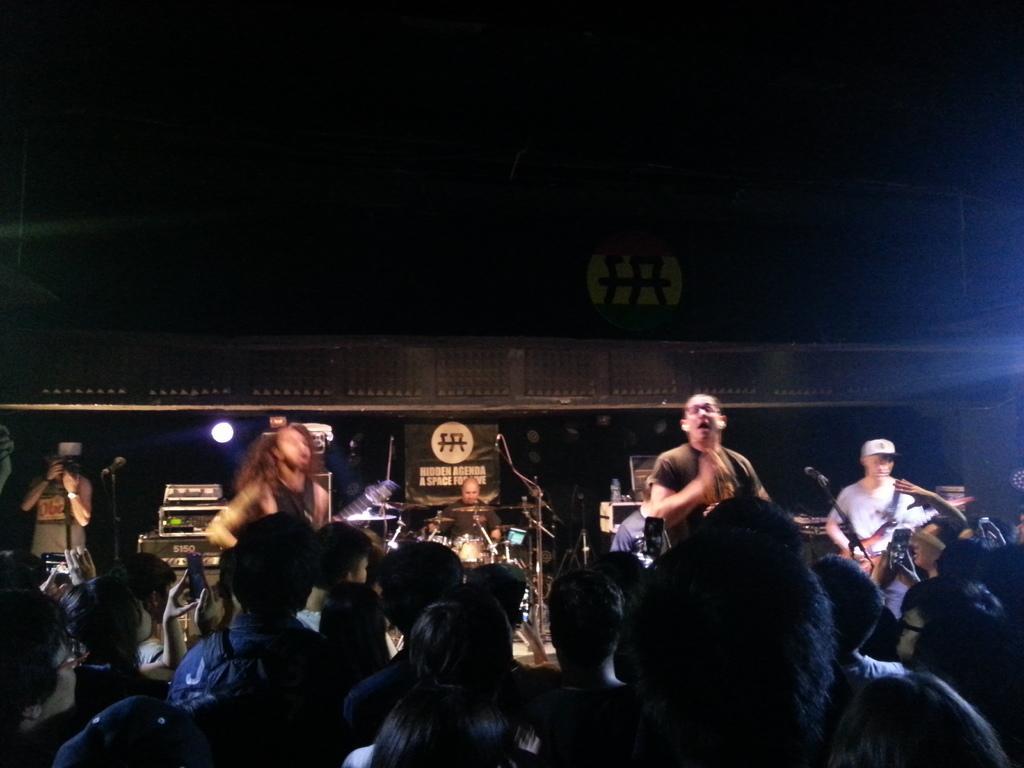Could you give a brief overview of what you see in this image? At the bottom, there are group of people sitting on the chair. Above of that, there are group of people sitting and standing, playing a guitar in front of the mike and singing a song and playing musical instruments. The background is dark in color. In the left bottom, there is a person standing and clicking photos and a light visible. This image is taken on the stage during night time. 